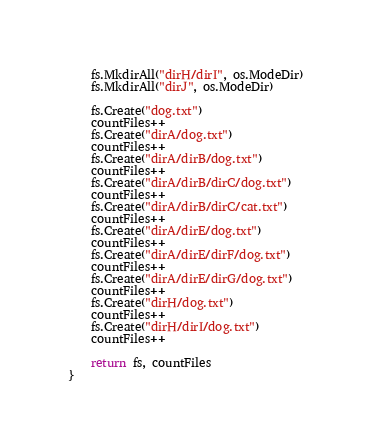Convert code to text. <code><loc_0><loc_0><loc_500><loc_500><_Go_>	fs.MkdirAll("dirH/dirI", os.ModeDir)
	fs.MkdirAll("dirJ", os.ModeDir)

	fs.Create("dog.txt")
	countFiles++
	fs.Create("dirA/dog.txt")
	countFiles++
	fs.Create("dirA/dirB/dog.txt")
	countFiles++
	fs.Create("dirA/dirB/dirC/dog.txt")
	countFiles++
	fs.Create("dirA/dirB/dirC/cat.txt")
	countFiles++
	fs.Create("dirA/dirE/dog.txt")
	countFiles++
	fs.Create("dirA/dirE/dirF/dog.txt")
	countFiles++
	fs.Create("dirA/dirE/dirG/dog.txt")
	countFiles++
	fs.Create("dirH/dog.txt")
	countFiles++
	fs.Create("dirH/dirI/dog.txt")
	countFiles++

	return fs, countFiles
}
</code> 